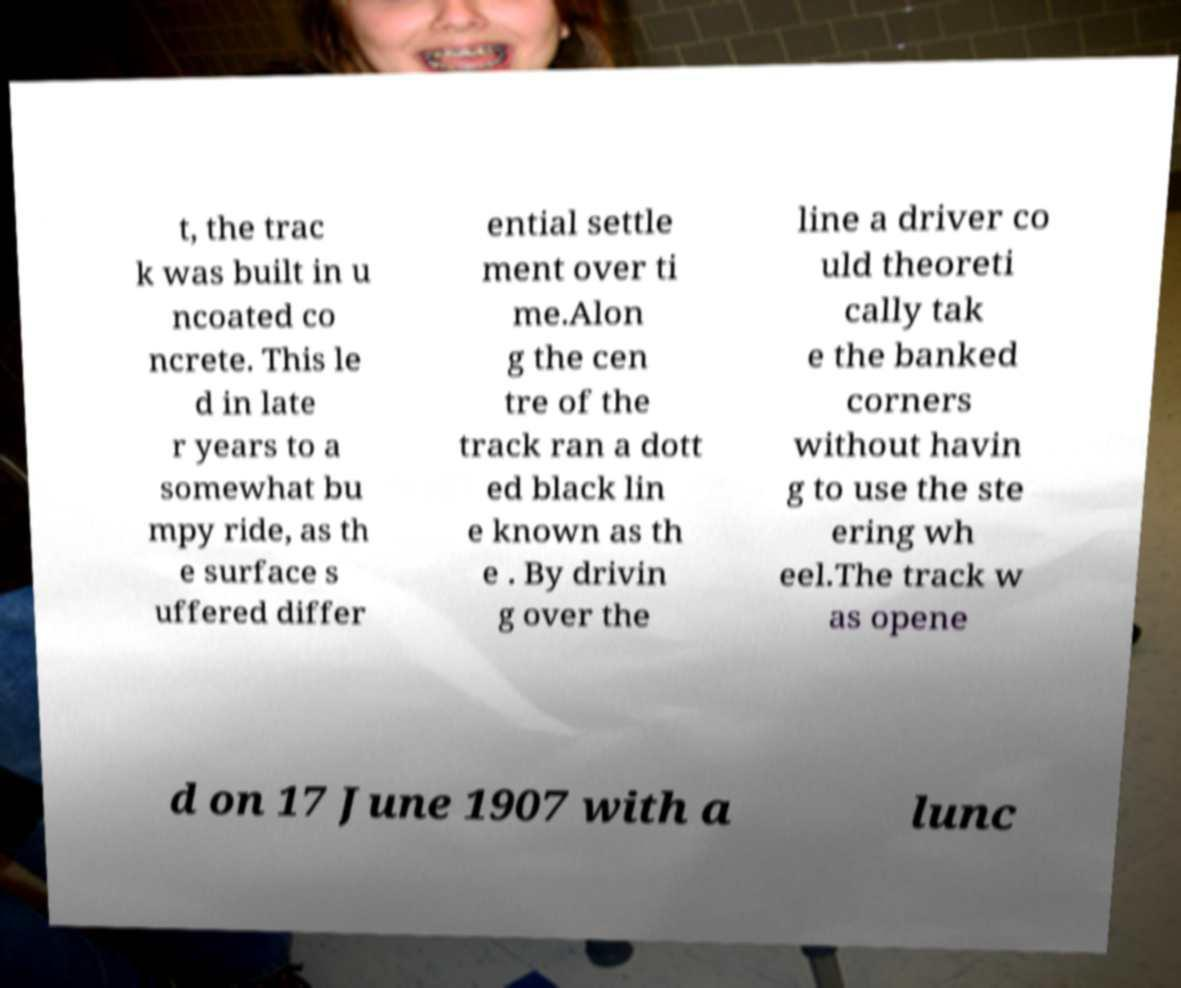Please identify and transcribe the text found in this image. t, the trac k was built in u ncoated co ncrete. This le d in late r years to a somewhat bu mpy ride, as th e surface s uffered differ ential settle ment over ti me.Alon g the cen tre of the track ran a dott ed black lin e known as th e . By drivin g over the line a driver co uld theoreti cally tak e the banked corners without havin g to use the ste ering wh eel.The track w as opene d on 17 June 1907 with a lunc 